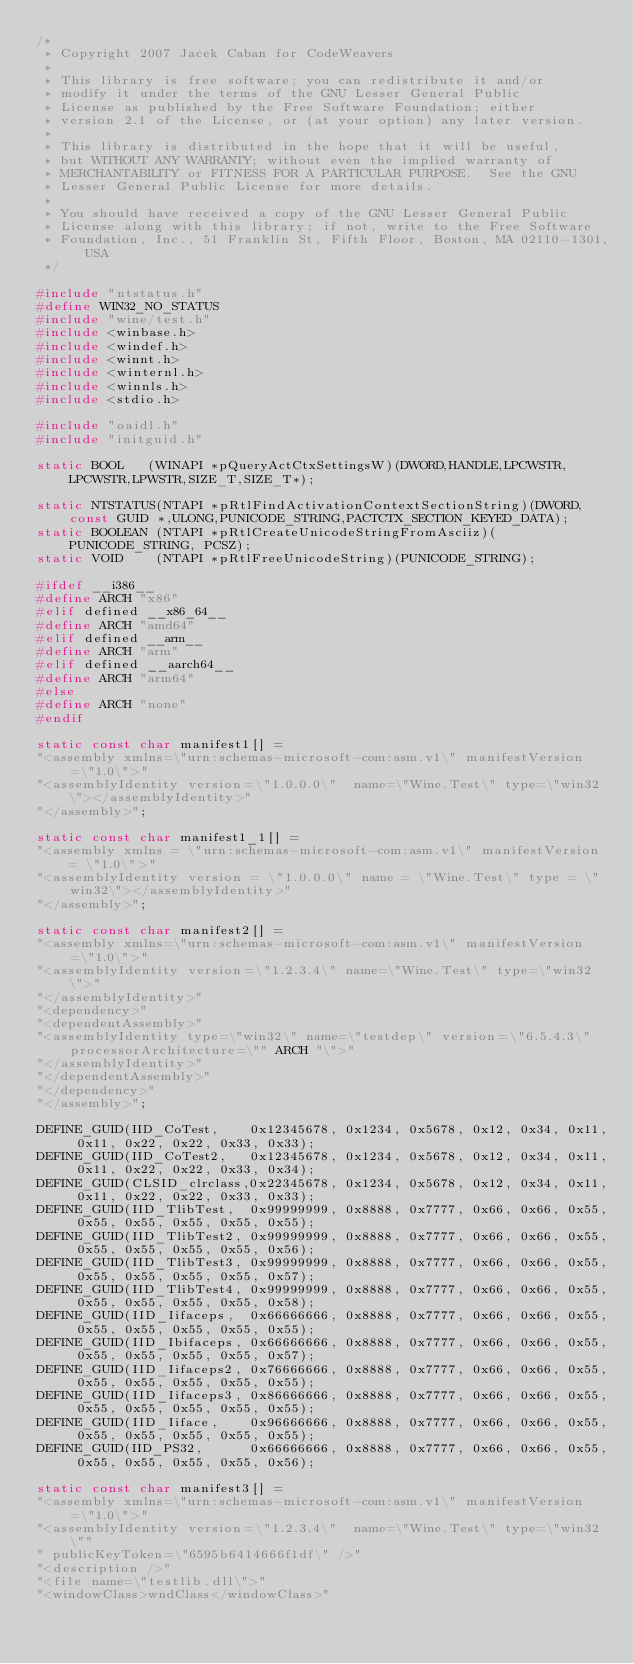<code> <loc_0><loc_0><loc_500><loc_500><_C_>/*
 * Copyright 2007 Jacek Caban for CodeWeavers
 *
 * This library is free software; you can redistribute it and/or
 * modify it under the terms of the GNU Lesser General Public
 * License as published by the Free Software Foundation; either
 * version 2.1 of the License, or (at your option) any later version.
 *
 * This library is distributed in the hope that it will be useful,
 * but WITHOUT ANY WARRANTY; without even the implied warranty of
 * MERCHANTABILITY or FITNESS FOR A PARTICULAR PURPOSE.  See the GNU
 * Lesser General Public License for more details.
 *
 * You should have received a copy of the GNU Lesser General Public
 * License along with this library; if not, write to the Free Software
 * Foundation, Inc., 51 Franklin St, Fifth Floor, Boston, MA 02110-1301, USA
 */

#include "ntstatus.h"
#define WIN32_NO_STATUS
#include "wine/test.h"
#include <winbase.h>
#include <windef.h>
#include <winnt.h>
#include <winternl.h>
#include <winnls.h>
#include <stdio.h>

#include "oaidl.h"
#include "initguid.h"

static BOOL   (WINAPI *pQueryActCtxSettingsW)(DWORD,HANDLE,LPCWSTR,LPCWSTR,LPWSTR,SIZE_T,SIZE_T*);

static NTSTATUS(NTAPI *pRtlFindActivationContextSectionString)(DWORD,const GUID *,ULONG,PUNICODE_STRING,PACTCTX_SECTION_KEYED_DATA);
static BOOLEAN (NTAPI *pRtlCreateUnicodeStringFromAsciiz)(PUNICODE_STRING, PCSZ);
static VOID    (NTAPI *pRtlFreeUnicodeString)(PUNICODE_STRING);

#ifdef __i386__
#define ARCH "x86"
#elif defined __x86_64__
#define ARCH "amd64"
#elif defined __arm__
#define ARCH "arm"
#elif defined __aarch64__
#define ARCH "arm64"
#else
#define ARCH "none"
#endif

static const char manifest1[] =
"<assembly xmlns=\"urn:schemas-microsoft-com:asm.v1\" manifestVersion=\"1.0\">"
"<assemblyIdentity version=\"1.0.0.0\"  name=\"Wine.Test\" type=\"win32\"></assemblyIdentity>"
"</assembly>";

static const char manifest1_1[] =
"<assembly xmlns = \"urn:schemas-microsoft-com:asm.v1\" manifestVersion = \"1.0\">"
"<assemblyIdentity version = \"1.0.0.0\" name = \"Wine.Test\" type = \"win32\"></assemblyIdentity>"
"</assembly>";

static const char manifest2[] =
"<assembly xmlns=\"urn:schemas-microsoft-com:asm.v1\" manifestVersion=\"1.0\">"
"<assemblyIdentity version=\"1.2.3.4\" name=\"Wine.Test\" type=\"win32\">"
"</assemblyIdentity>"
"<dependency>"
"<dependentAssembly>"
"<assemblyIdentity type=\"win32\" name=\"testdep\" version=\"6.5.4.3\" processorArchitecture=\"" ARCH "\">"
"</assemblyIdentity>"
"</dependentAssembly>"
"</dependency>"
"</assembly>";

DEFINE_GUID(IID_CoTest,    0x12345678, 0x1234, 0x5678, 0x12, 0x34, 0x11, 0x11, 0x22, 0x22, 0x33, 0x33);
DEFINE_GUID(IID_CoTest2,   0x12345678, 0x1234, 0x5678, 0x12, 0x34, 0x11, 0x11, 0x22, 0x22, 0x33, 0x34);
DEFINE_GUID(CLSID_clrclass,0x22345678, 0x1234, 0x5678, 0x12, 0x34, 0x11, 0x11, 0x22, 0x22, 0x33, 0x33);
DEFINE_GUID(IID_TlibTest,  0x99999999, 0x8888, 0x7777, 0x66, 0x66, 0x55, 0x55, 0x55, 0x55, 0x55, 0x55);
DEFINE_GUID(IID_TlibTest2, 0x99999999, 0x8888, 0x7777, 0x66, 0x66, 0x55, 0x55, 0x55, 0x55, 0x55, 0x56);
DEFINE_GUID(IID_TlibTest3, 0x99999999, 0x8888, 0x7777, 0x66, 0x66, 0x55, 0x55, 0x55, 0x55, 0x55, 0x57);
DEFINE_GUID(IID_TlibTest4, 0x99999999, 0x8888, 0x7777, 0x66, 0x66, 0x55, 0x55, 0x55, 0x55, 0x55, 0x58);
DEFINE_GUID(IID_Iifaceps,  0x66666666, 0x8888, 0x7777, 0x66, 0x66, 0x55, 0x55, 0x55, 0x55, 0x55, 0x55);
DEFINE_GUID(IID_Ibifaceps, 0x66666666, 0x8888, 0x7777, 0x66, 0x66, 0x55, 0x55, 0x55, 0x55, 0x55, 0x57);
DEFINE_GUID(IID_Iifaceps2, 0x76666666, 0x8888, 0x7777, 0x66, 0x66, 0x55, 0x55, 0x55, 0x55, 0x55, 0x55);
DEFINE_GUID(IID_Iifaceps3, 0x86666666, 0x8888, 0x7777, 0x66, 0x66, 0x55, 0x55, 0x55, 0x55, 0x55, 0x55);
DEFINE_GUID(IID_Iiface,    0x96666666, 0x8888, 0x7777, 0x66, 0x66, 0x55, 0x55, 0x55, 0x55, 0x55, 0x55);
DEFINE_GUID(IID_PS32,      0x66666666, 0x8888, 0x7777, 0x66, 0x66, 0x55, 0x55, 0x55, 0x55, 0x55, 0x56);

static const char manifest3[] =
"<assembly xmlns=\"urn:schemas-microsoft-com:asm.v1\" manifestVersion=\"1.0\">"
"<assemblyIdentity version=\"1.2.3.4\"  name=\"Wine.Test\" type=\"win32\""
" publicKeyToken=\"6595b6414666f1df\" />"
"<description />"
"<file name=\"testlib.dll\">"
"<windowClass>wndClass</windowClass>"</code> 